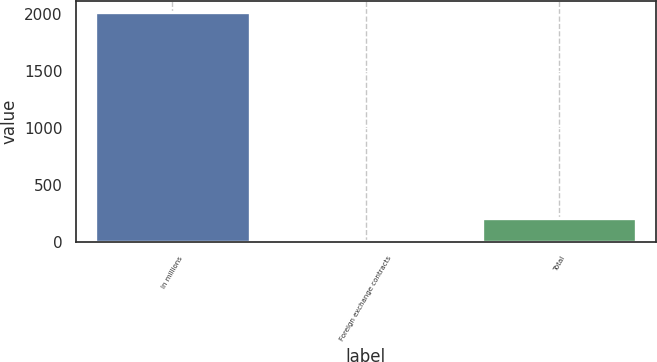<chart> <loc_0><loc_0><loc_500><loc_500><bar_chart><fcel>In millions<fcel>Foreign exchange contracts<fcel>Total<nl><fcel>2018<fcel>10<fcel>210.8<nl></chart> 